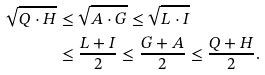<formula> <loc_0><loc_0><loc_500><loc_500>\sqrt { Q \cdot H } & \leq \sqrt { A \cdot G } \leq \sqrt { L \cdot I } \\ & \leq \frac { L + I } { 2 } \leq \frac { G + A } { 2 } \leq \frac { Q + H } { 2 } .</formula> 